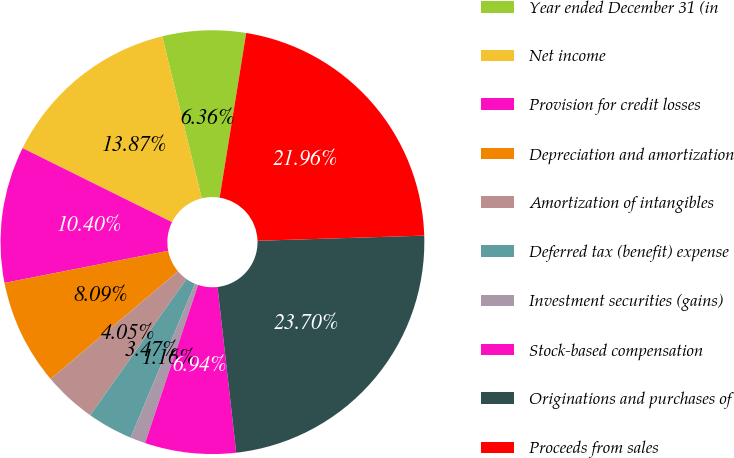Convert chart. <chart><loc_0><loc_0><loc_500><loc_500><pie_chart><fcel>Year ended December 31 (in<fcel>Net income<fcel>Provision for credit losses<fcel>Depreciation and amortization<fcel>Amortization of intangibles<fcel>Deferred tax (benefit) expense<fcel>Investment securities (gains)<fcel>Stock-based compensation<fcel>Originations and purchases of<fcel>Proceeds from sales<nl><fcel>6.36%<fcel>13.87%<fcel>10.4%<fcel>8.09%<fcel>4.05%<fcel>3.47%<fcel>1.16%<fcel>6.94%<fcel>23.7%<fcel>21.96%<nl></chart> 